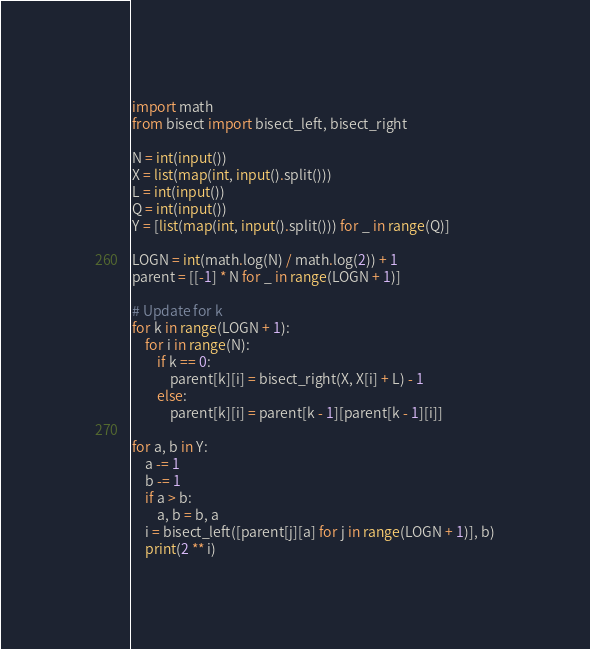Convert code to text. <code><loc_0><loc_0><loc_500><loc_500><_Python_>import math
from bisect import bisect_left, bisect_right

N = int(input())
X = list(map(int, input().split()))
L = int(input())
Q = int(input())
Y = [list(map(int, input().split())) for _ in range(Q)]

LOGN = int(math.log(N) / math.log(2)) + 1
parent = [[-1] * N for _ in range(LOGN + 1)]

# Update for k
for k in range(LOGN + 1):
    for i in range(N):
        if k == 0:
            parent[k][i] = bisect_right(X, X[i] + L) - 1
        else:
            parent[k][i] = parent[k - 1][parent[k - 1][i]]

for a, b in Y:
    a -= 1
    b -= 1
    if a > b:
        a, b = b, a
    i = bisect_left([parent[j][a] for j in range(LOGN + 1)], b)
    print(2 ** i)
</code> 